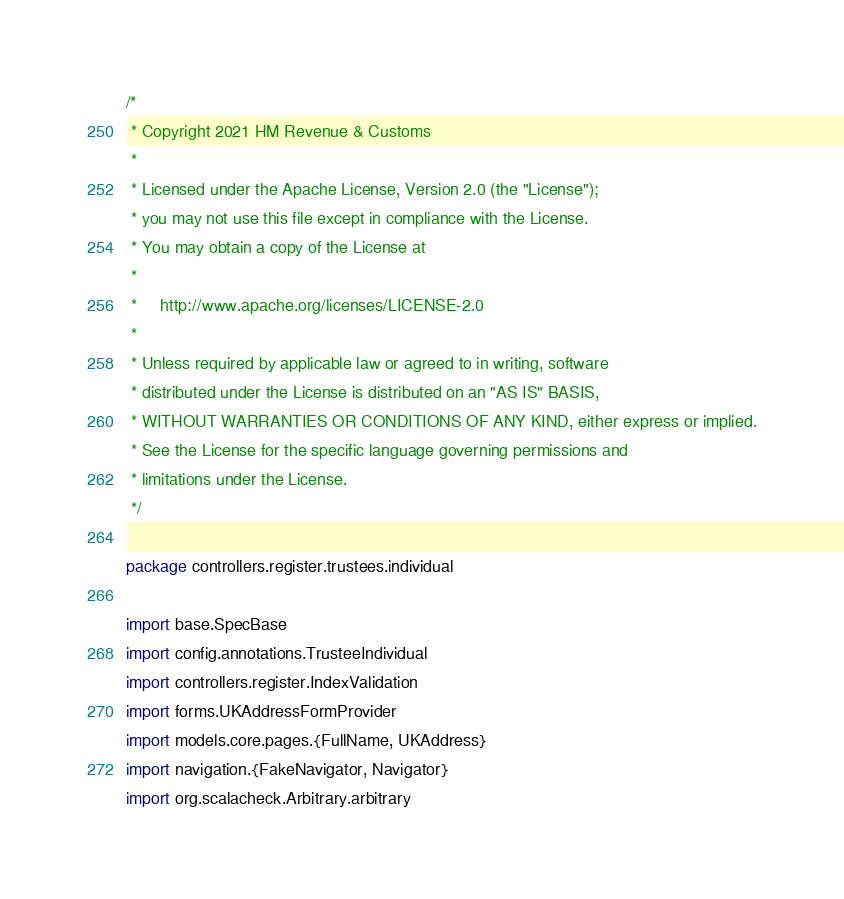Convert code to text. <code><loc_0><loc_0><loc_500><loc_500><_Scala_>/*
 * Copyright 2021 HM Revenue & Customs
 *
 * Licensed under the Apache License, Version 2.0 (the "License");
 * you may not use this file except in compliance with the License.
 * You may obtain a copy of the License at
 *
 *     http://www.apache.org/licenses/LICENSE-2.0
 *
 * Unless required by applicable law or agreed to in writing, software
 * distributed under the License is distributed on an "AS IS" BASIS,
 * WITHOUT WARRANTIES OR CONDITIONS OF ANY KIND, either express or implied.
 * See the License for the specific language governing permissions and
 * limitations under the License.
 */

package controllers.register.trustees.individual

import base.SpecBase
import config.annotations.TrusteeIndividual
import controllers.register.IndexValidation
import forms.UKAddressFormProvider
import models.core.pages.{FullName, UKAddress}
import navigation.{FakeNavigator, Navigator}
import org.scalacheck.Arbitrary.arbitrary</code> 